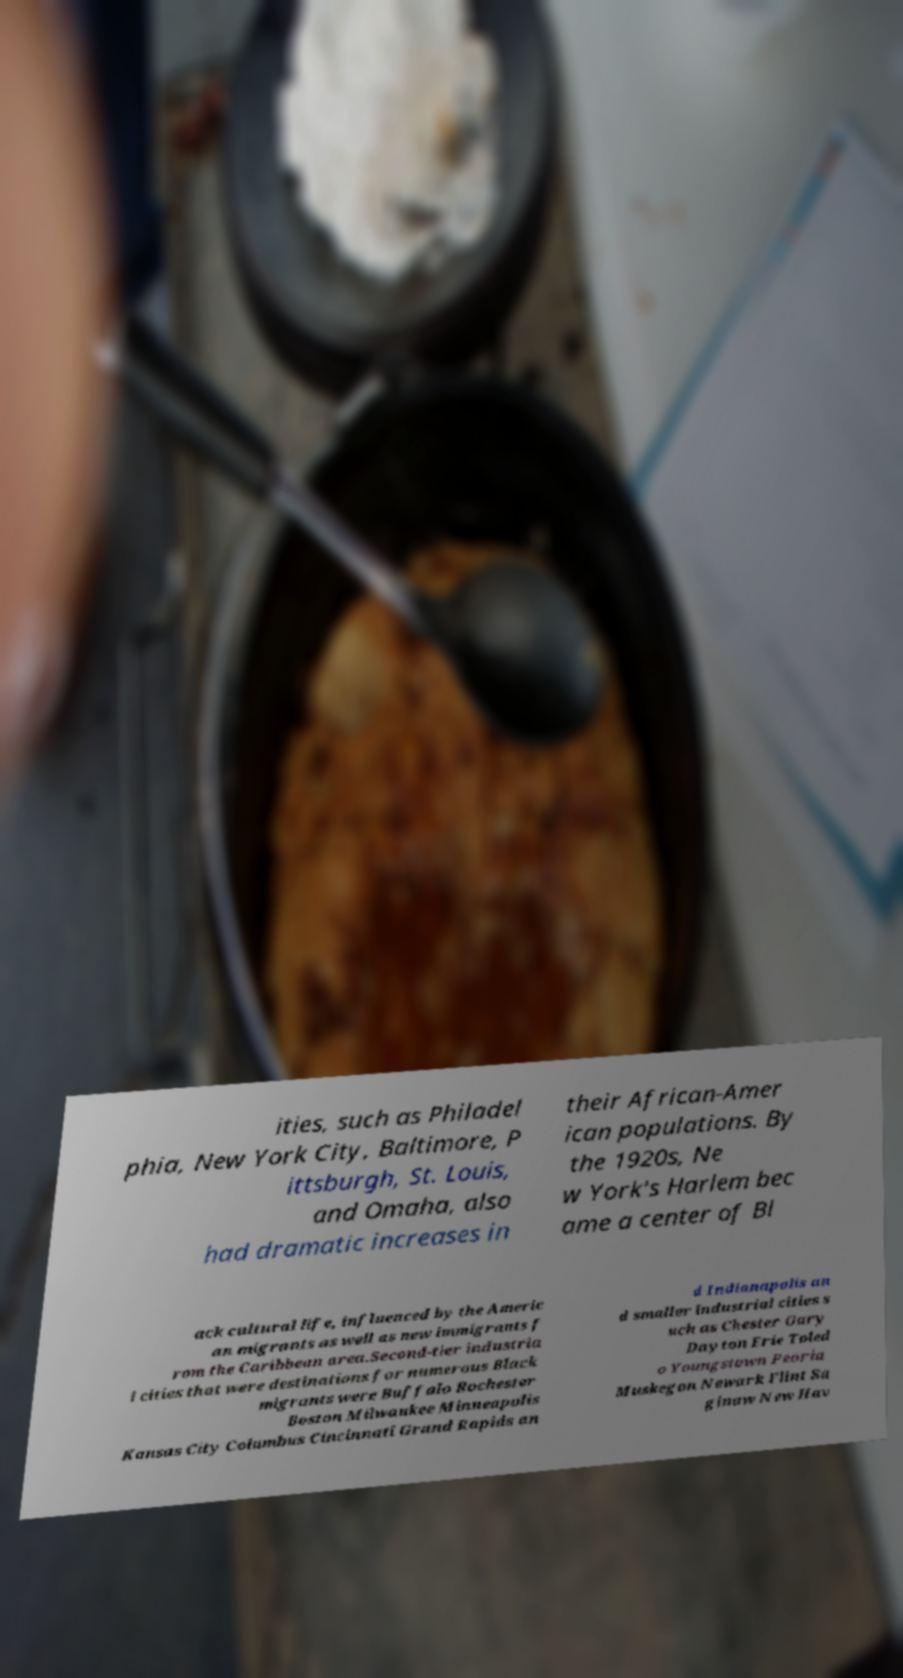Please read and relay the text visible in this image. What does it say? ities, such as Philadel phia, New York City, Baltimore, P ittsburgh, St. Louis, and Omaha, also had dramatic increases in their African-Amer ican populations. By the 1920s, Ne w York's Harlem bec ame a center of Bl ack cultural life, influenced by the Americ an migrants as well as new immigrants f rom the Caribbean area.Second-tier industria l cities that were destinations for numerous Black migrants were Buffalo Rochester Boston Milwaukee Minneapolis Kansas City Columbus Cincinnati Grand Rapids an d Indianapolis an d smaller industrial cities s uch as Chester Gary Dayton Erie Toled o Youngstown Peoria Muskegon Newark Flint Sa ginaw New Hav 